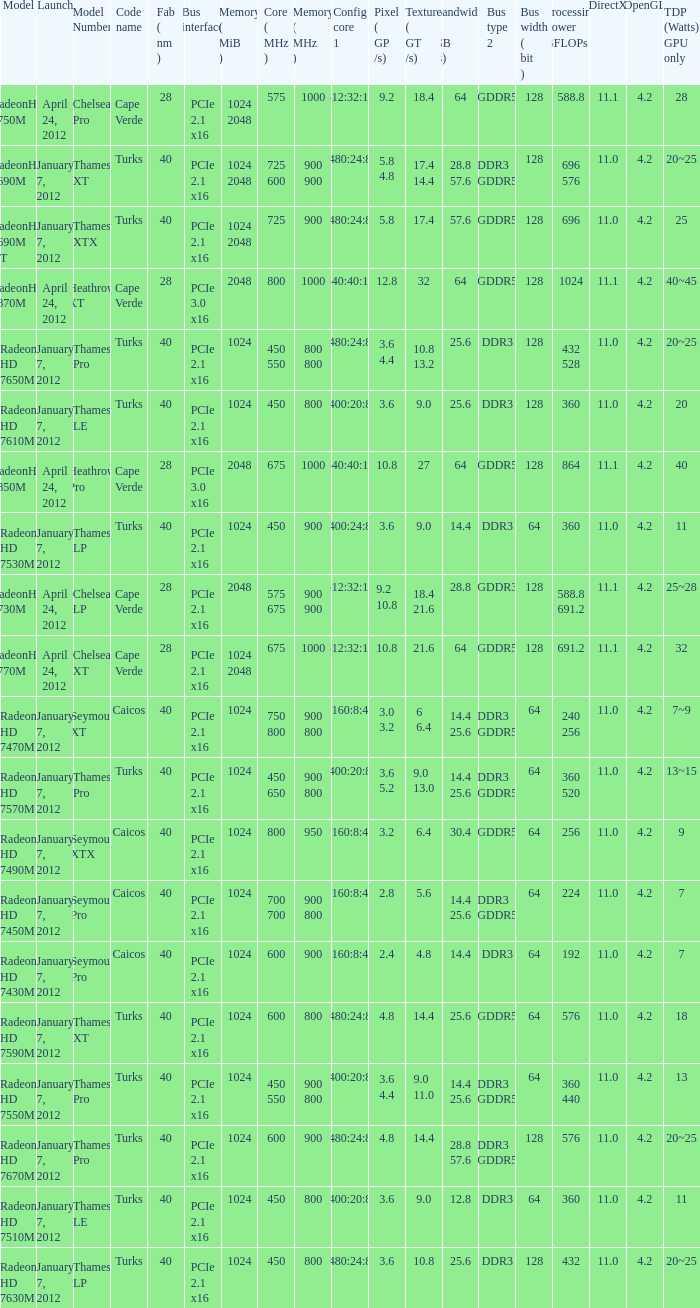What was the maximum fab (nm)? 40.0. 